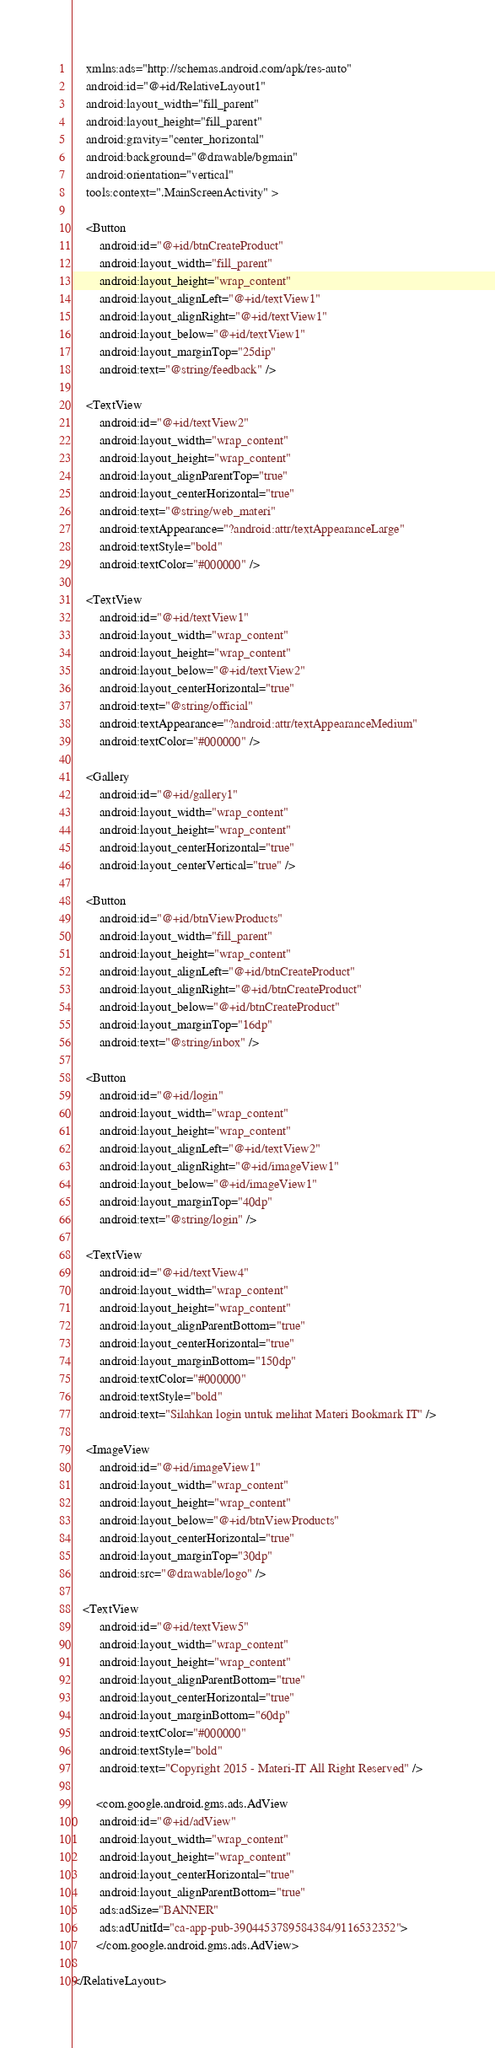Convert code to text. <code><loc_0><loc_0><loc_500><loc_500><_XML_>    xmlns:ads="http://schemas.android.com/apk/res-auto"
    android:id="@+id/RelativeLayout1"
    android:layout_width="fill_parent"
    android:layout_height="fill_parent"
    android:gravity="center_horizontal"
    android:background="@drawable/bgmain"
    android:orientation="vertical"
    tools:context=".MainScreenActivity" >

    <Button
        android:id="@+id/btnCreateProduct"
        android:layout_width="fill_parent"
        android:layout_height="wrap_content"
        android:layout_alignLeft="@+id/textView1"
        android:layout_alignRight="@+id/textView1"
        android:layout_below="@+id/textView1"
        android:layout_marginTop="25dip"
        android:text="@string/feedback" />

    <TextView
        android:id="@+id/textView2"
        android:layout_width="wrap_content"
        android:layout_height="wrap_content"
        android:layout_alignParentTop="true"
        android:layout_centerHorizontal="true"
        android:text="@string/web_materi"
        android:textAppearance="?android:attr/textAppearanceLarge"
        android:textStyle="bold"
        android:textColor="#000000" />

    <TextView
        android:id="@+id/textView1"
        android:layout_width="wrap_content"
        android:layout_height="wrap_content"
        android:layout_below="@+id/textView2"
        android:layout_centerHorizontal="true"
        android:text="@string/official"
        android:textAppearance="?android:attr/textAppearanceMedium"
        android:textColor="#000000" />

    <Gallery
        android:id="@+id/gallery1"
        android:layout_width="wrap_content"
        android:layout_height="wrap_content"
        android:layout_centerHorizontal="true"
        android:layout_centerVertical="true" />

    <Button
        android:id="@+id/btnViewProducts"
        android:layout_width="fill_parent"
        android:layout_height="wrap_content"
        android:layout_alignLeft="@+id/btnCreateProduct"
        android:layout_alignRight="@+id/btnCreateProduct"
        android:layout_below="@+id/btnCreateProduct"
        android:layout_marginTop="16dp"
        android:text="@string/inbox" />

    <Button
        android:id="@+id/login"
        android:layout_width="wrap_content"
        android:layout_height="wrap_content"
        android:layout_alignLeft="@+id/textView2"
        android:layout_alignRight="@+id/imageView1"
        android:layout_below="@+id/imageView1"
        android:layout_marginTop="40dp"
        android:text="@string/login" />
    
    <TextView
        android:id="@+id/textView4"
        android:layout_width="wrap_content"
        android:layout_height="wrap_content"
        android:layout_alignParentBottom="true"
        android:layout_centerHorizontal="true"
        android:layout_marginBottom="150dp"
        android:textColor="#000000"
        android:textStyle="bold"
        android:text="Silahkan login untuk melihat Materi Bookmark IT" />

    <ImageView
        android:id="@+id/imageView1"
        android:layout_width="wrap_content"
        android:layout_height="wrap_content"
        android:layout_below="@+id/btnViewProducts"
        android:layout_centerHorizontal="true"
        android:layout_marginTop="30dp"
        android:src="@drawable/logo" />

   <TextView
        android:id="@+id/textView5"
        android:layout_width="wrap_content"
        android:layout_height="wrap_content"
        android:layout_alignParentBottom="true"
        android:layout_centerHorizontal="true"
        android:layout_marginBottom="60dp"
        android:textColor="#000000"
        android:textStyle="bold"
        android:text="Copyright 2015 - Materi-IT All Right Reserved" />
   
       <com.google.android.gms.ads.AdView
        android:id="@+id/adView"
        android:layout_width="wrap_content"
        android:layout_height="wrap_content"
        android:layout_centerHorizontal="true"
        android:layout_alignParentBottom="true"
        ads:adSize="BANNER"
        ads:adUnitId="ca-app-pub-3904453789584384/9116532352">
       </com.google.android.gms.ads.AdView>

</RelativeLayout></code> 